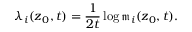<formula> <loc_0><loc_0><loc_500><loc_500>\lambda _ { i } ( z _ { 0 } , t ) = \frac { 1 } { 2 t } \log \mathfrak { m } _ { i } ( z _ { 0 } , t ) .</formula> 